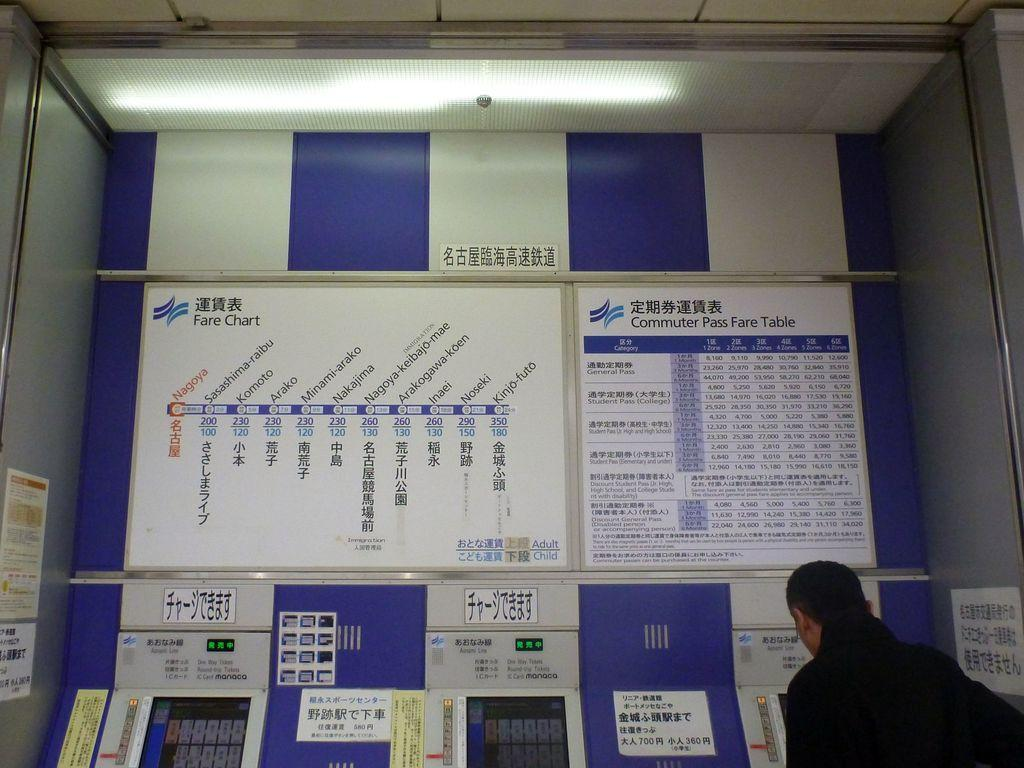<image>
Write a terse but informative summary of the picture. A person stands at a ticket machine with a sign reading Commuter Pass Fare Table. 